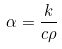Convert formula to latex. <formula><loc_0><loc_0><loc_500><loc_500>\alpha = { \frac { k } { c \rho } }</formula> 